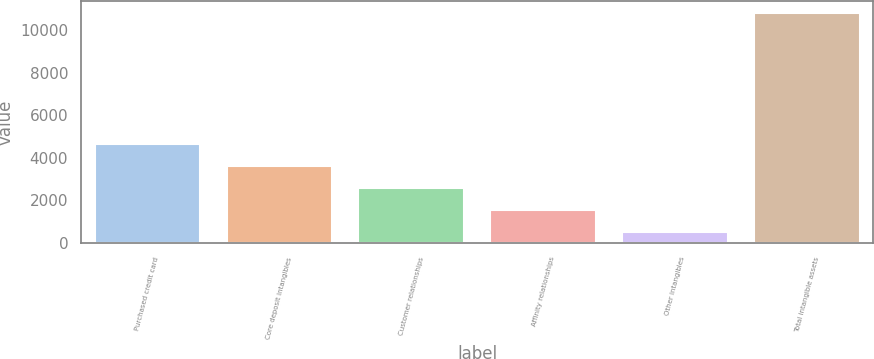<chart> <loc_0><loc_0><loc_500><loc_500><bar_chart><fcel>Purchased credit card<fcel>Core deposit intangibles<fcel>Customer relationships<fcel>Affinity relationships<fcel>Other intangibles<fcel>Total intangible assets<nl><fcel>4634.2<fcel>3601.9<fcel>2569.6<fcel>1537.3<fcel>505<fcel>10828<nl></chart> 